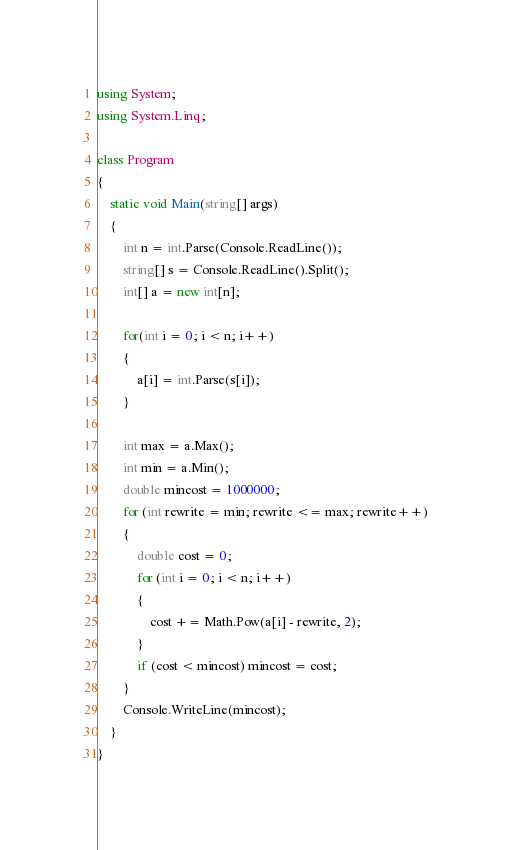<code> <loc_0><loc_0><loc_500><loc_500><_C#_>using System;
using System.Linq;

class Program
{
    static void Main(string[] args)
    {
        int n = int.Parse(Console.ReadLine());
        string[] s = Console.ReadLine().Split();
        int[] a = new int[n];

        for(int i = 0; i < n; i++)
        {
            a[i] = int.Parse(s[i]);
        }

        int max = a.Max();
        int min = a.Min();
        double mincost = 1000000;
        for (int rewrite = min; rewrite <= max; rewrite++)
        {
            double cost = 0;
            for (int i = 0; i < n; i++)
            {
                cost += Math.Pow(a[i] - rewrite, 2);
            }
            if (cost < mincost) mincost = cost;
        }
        Console.WriteLine(mincost);
    }
}
</code> 